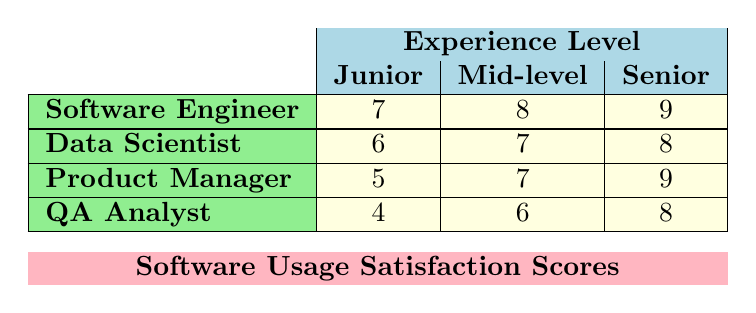What is the satisfaction score for Junior Software Engineers? From the table, look under the "Software Engineer" row and the "Junior" column. The satisfaction score listed is 7.
Answer: 7 What is the highest satisfaction score recorded in the table? By scanning through all the cells in the table, the highest satisfaction score is found in the "Senior" column for both Software Engineers and Product Managers, which is 9.
Answer: 9 Is the satisfaction score of Senior Data Scientists higher than that of Mid-level QA Analysts? Checking the scores, the Senior Data Scientist has a score of 8, while the Mid-level QA Analyst has a score of 6. Since 8 is greater than 6, the statement is true.
Answer: Yes What is the average satisfaction score for Product Managers? The scores for Product Managers are 5 (Junior), 7 (Mid-level), and 9 (Senior). To find the average, sum these scores (5 + 7 + 9 = 21) and divide by the number of levels (3), giving an average of 21/3 = 7.
Answer: 7 How does the satisfaction score for Senior QA Analysts compare with Junior Data Scientists? The score for Senior QA Analysts is 8, and for Junior Data Scientists, it is 6. Since 8 is greater than 6, the Senior QA Analyst has a higher score.
Answer: Senior QA Analysts are higher What is the difference in satisfaction scores between Mid-level Software Engineers and Junior Product Managers? The Mid-level Software Engineer has a score of 8, while the Junior Product Manager has a score of 5. The difference is calculated as 8 - 5 = 3.
Answer: 3 Are Junior QA Analysts more satisfied than Mid-level Data Scientists? The Junior QA Analyst has a score of 4, and the Mid-level Data Scientist has a score of 7. Since 4 is less than 7, Junior QA Analysts are not more satisfied.
Answer: No What is the total satisfaction score for all senior-level respondents? The Senior-level respondents' scores are from Software Engineers (9), Data Scientists (8), Product Managers (9), and QA Analysts (8). Summing these gives 9 + 8 + 9 + 8 = 34.
Answer: 34 